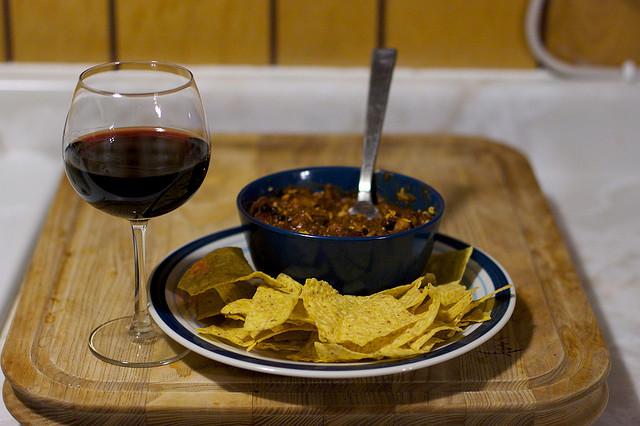Could that be chili?
Write a very short answer. Yes. What kind of food is this?
Answer briefly. Chili. What is the pattern on the trim of the plate?
Keep it brief. Stripe. What material is the tray?
Concise answer only. Wood. How many wine glasses are there?
Write a very short answer. 1. What object(s) is on the plate?
Answer briefly. Chips. Are all of these consumables produced or grown somewhere in Europe?
Answer briefly. No. What is the drink?
Be succinct. Wine. How many glasses are there?
Be succinct. 1. 